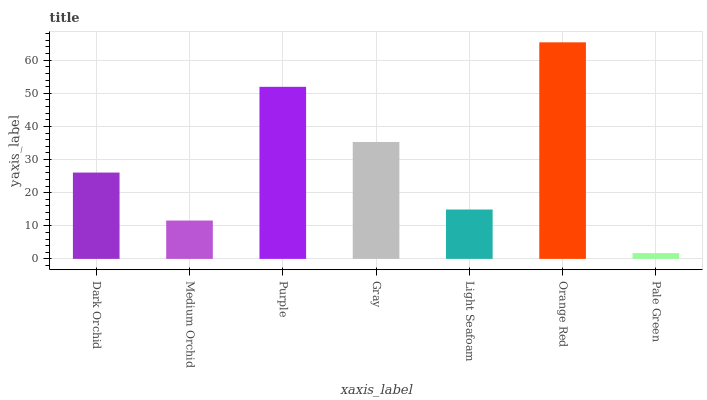Is Medium Orchid the minimum?
Answer yes or no. No. Is Medium Orchid the maximum?
Answer yes or no. No. Is Dark Orchid greater than Medium Orchid?
Answer yes or no. Yes. Is Medium Orchid less than Dark Orchid?
Answer yes or no. Yes. Is Medium Orchid greater than Dark Orchid?
Answer yes or no. No. Is Dark Orchid less than Medium Orchid?
Answer yes or no. No. Is Dark Orchid the high median?
Answer yes or no. Yes. Is Dark Orchid the low median?
Answer yes or no. Yes. Is Orange Red the high median?
Answer yes or no. No. Is Medium Orchid the low median?
Answer yes or no. No. 